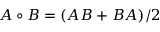<formula> <loc_0><loc_0><loc_500><loc_500>A \circ B = ( A B + B A ) / 2</formula> 